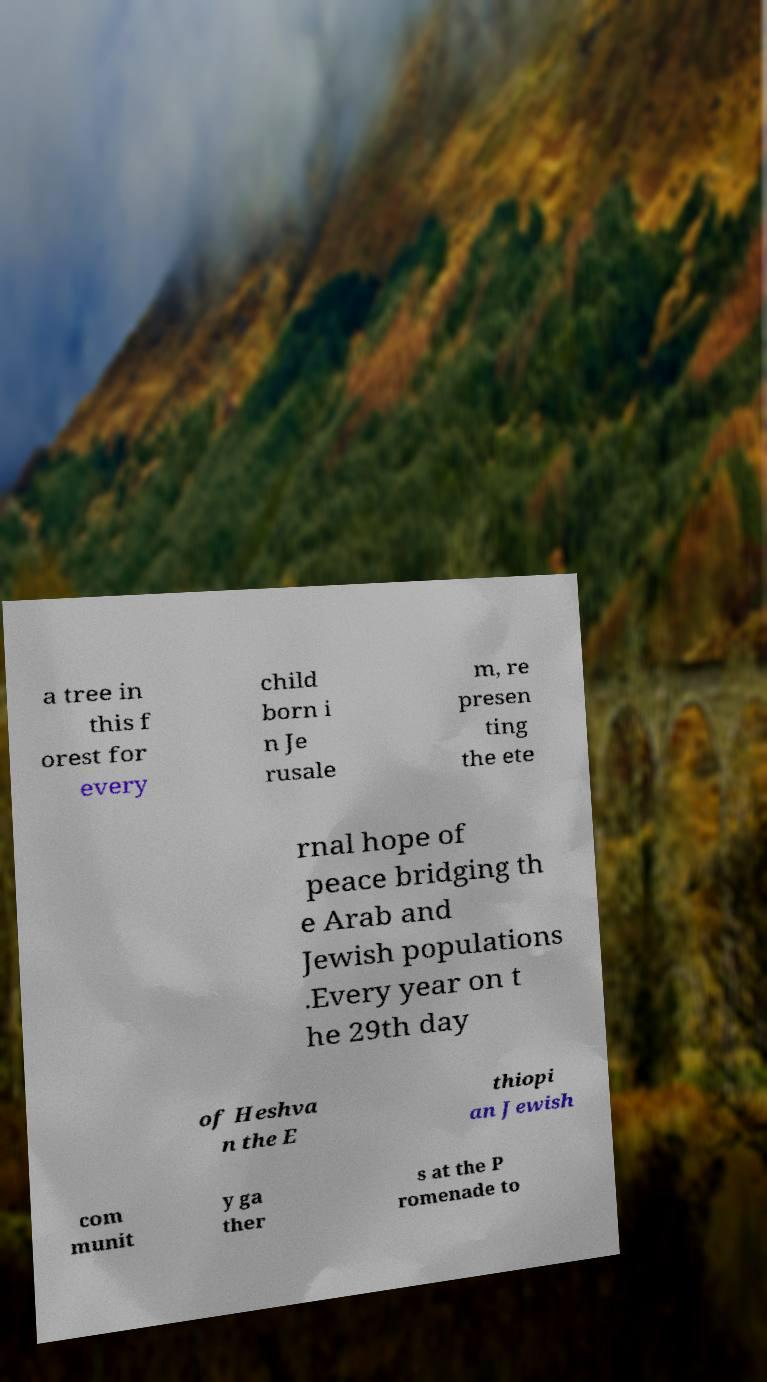Could you extract and type out the text from this image? a tree in this f orest for every child born i n Je rusale m, re presen ting the ete rnal hope of peace bridging th e Arab and Jewish populations .Every year on t he 29th day of Heshva n the E thiopi an Jewish com munit y ga ther s at the P romenade to 